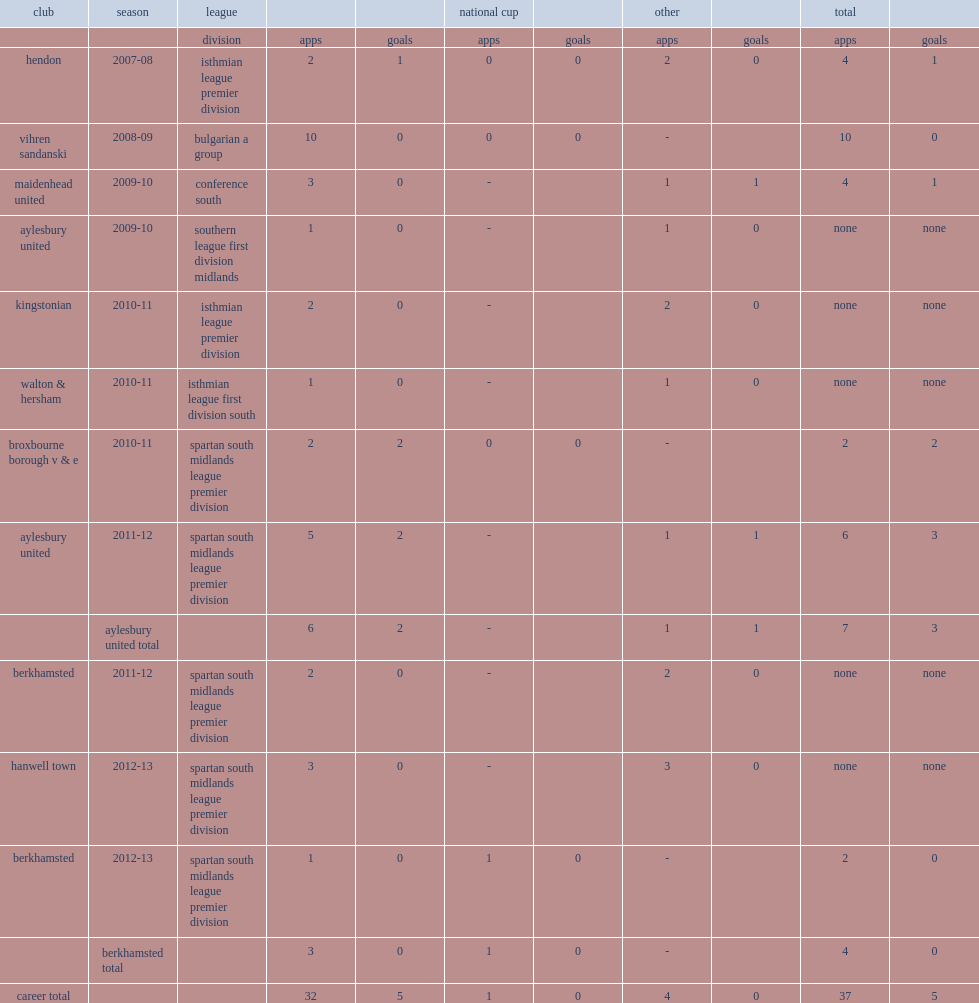In the 2010-11 season, which league did ivailo dimitrov join the club, broxbourne borough v & e? Spartan south midlands league premier division. 